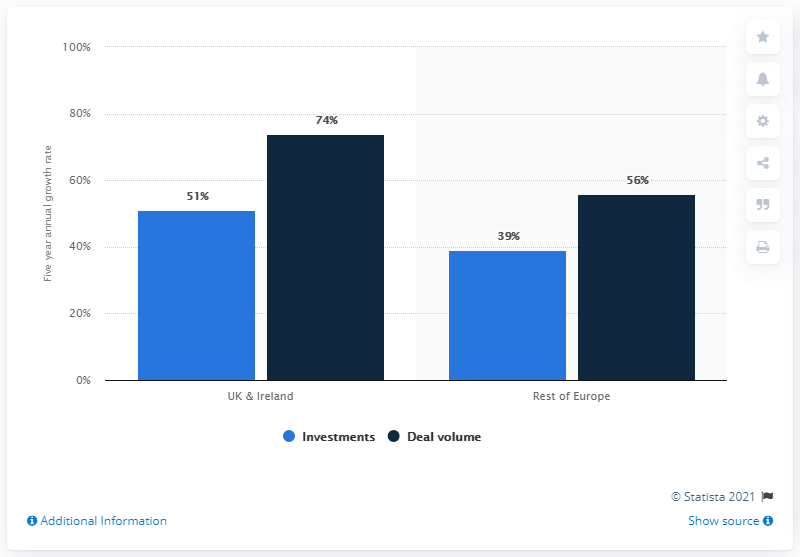Identify some key points in this picture. The total value of investments is approximately 90. The UK and Ireland have the highest percentage of a certain characteristic or attribute. 